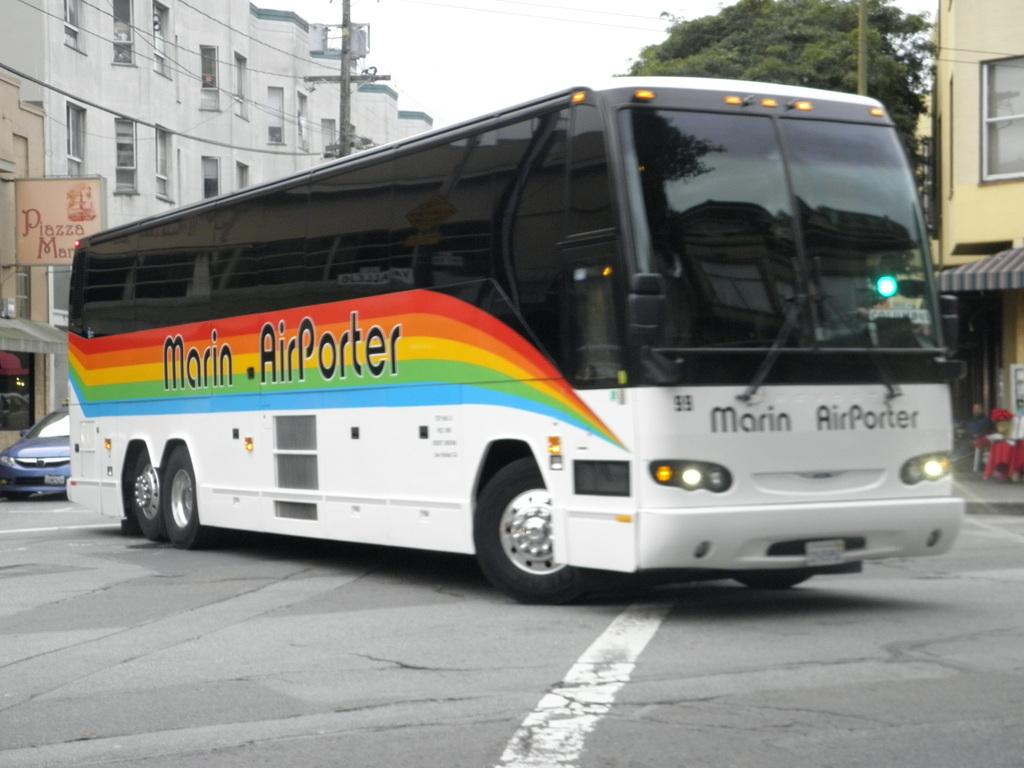What is the main subject of the image? The main subject of the image is a bus. Where is the bus located in the image? The bus is on a road in the image. What can be seen in the background of the image? There are buildings, a tree, and poles in the background of the image. What type of scarf is the giraffe wearing while playing with the ball in the image? There is no giraffe, scarf, or ball present in the image. The image only features a bus on a road with buildings, a tree, and poles in the background. 